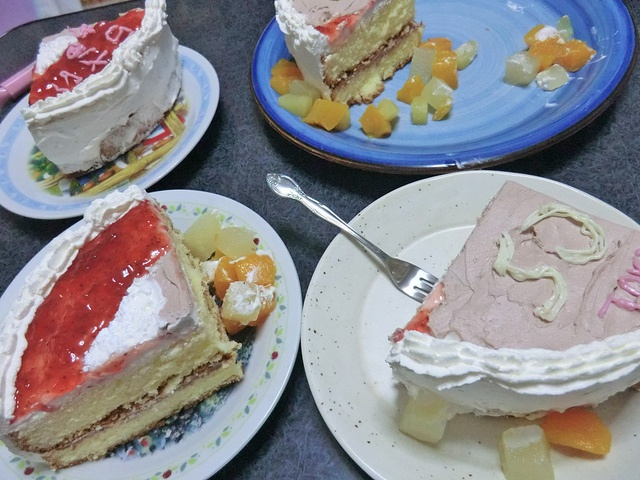Describe the objects in this image and their specific colors. I can see dining table in gray, black, and darkblue tones, cake in gray, brown, and lavender tones, cake in gray, darkgray, and lightgray tones, cake in gray, darkgray, lightgray, and brown tones, and cake in gray, olive, and darkgray tones in this image. 